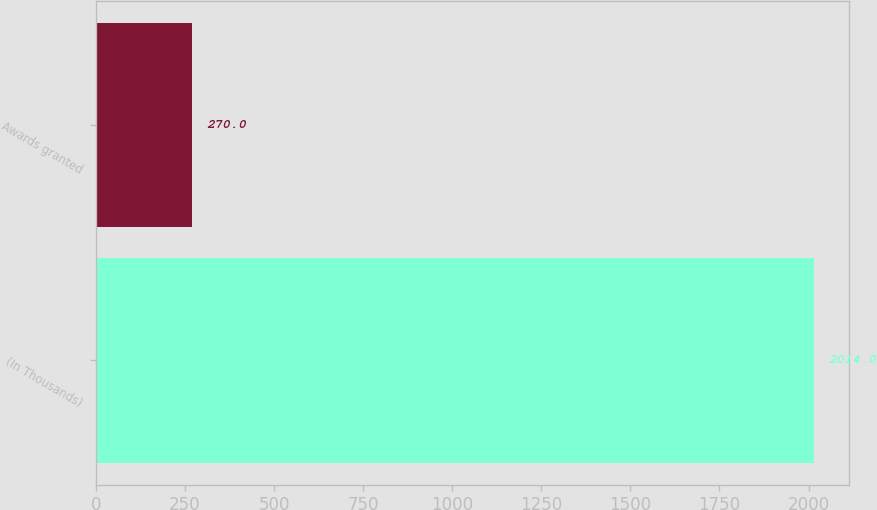<chart> <loc_0><loc_0><loc_500><loc_500><bar_chart><fcel>(In Thousands)<fcel>Awards granted<nl><fcel>2014<fcel>270<nl></chart> 